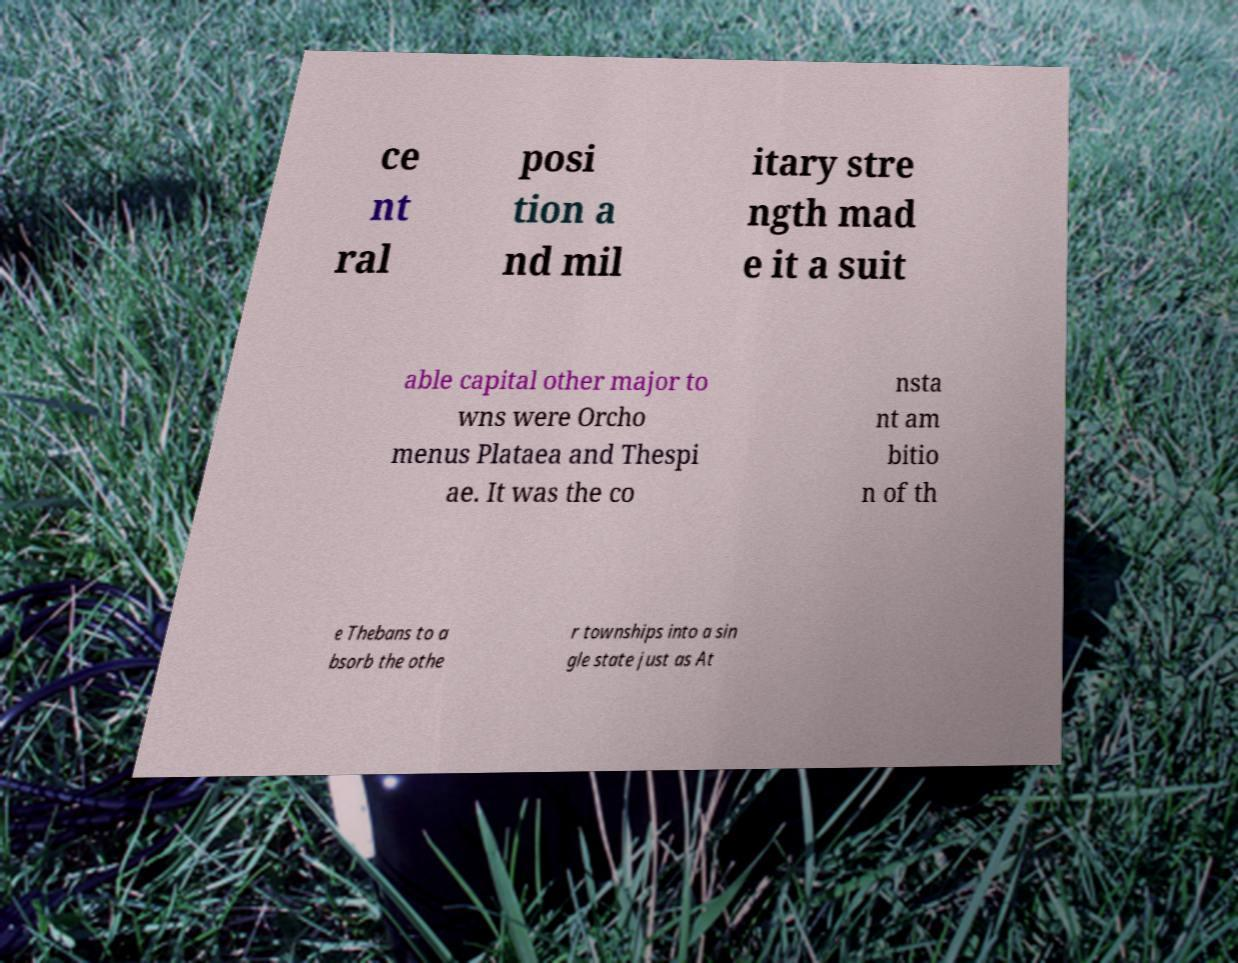Could you assist in decoding the text presented in this image and type it out clearly? ce nt ral posi tion a nd mil itary stre ngth mad e it a suit able capital other major to wns were Orcho menus Plataea and Thespi ae. It was the co nsta nt am bitio n of th e Thebans to a bsorb the othe r townships into a sin gle state just as At 